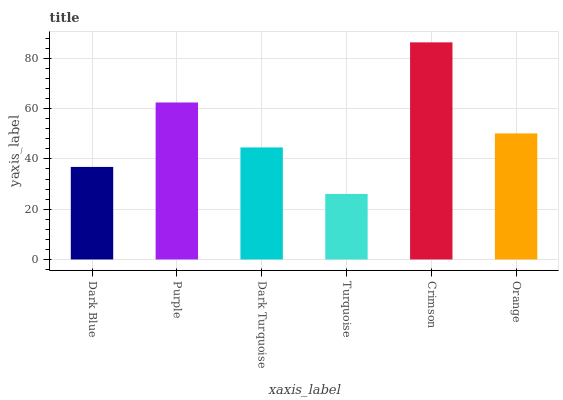Is Turquoise the minimum?
Answer yes or no. Yes. Is Crimson the maximum?
Answer yes or no. Yes. Is Purple the minimum?
Answer yes or no. No. Is Purple the maximum?
Answer yes or no. No. Is Purple greater than Dark Blue?
Answer yes or no. Yes. Is Dark Blue less than Purple?
Answer yes or no. Yes. Is Dark Blue greater than Purple?
Answer yes or no. No. Is Purple less than Dark Blue?
Answer yes or no. No. Is Orange the high median?
Answer yes or no. Yes. Is Dark Turquoise the low median?
Answer yes or no. Yes. Is Dark Blue the high median?
Answer yes or no. No. Is Dark Blue the low median?
Answer yes or no. No. 